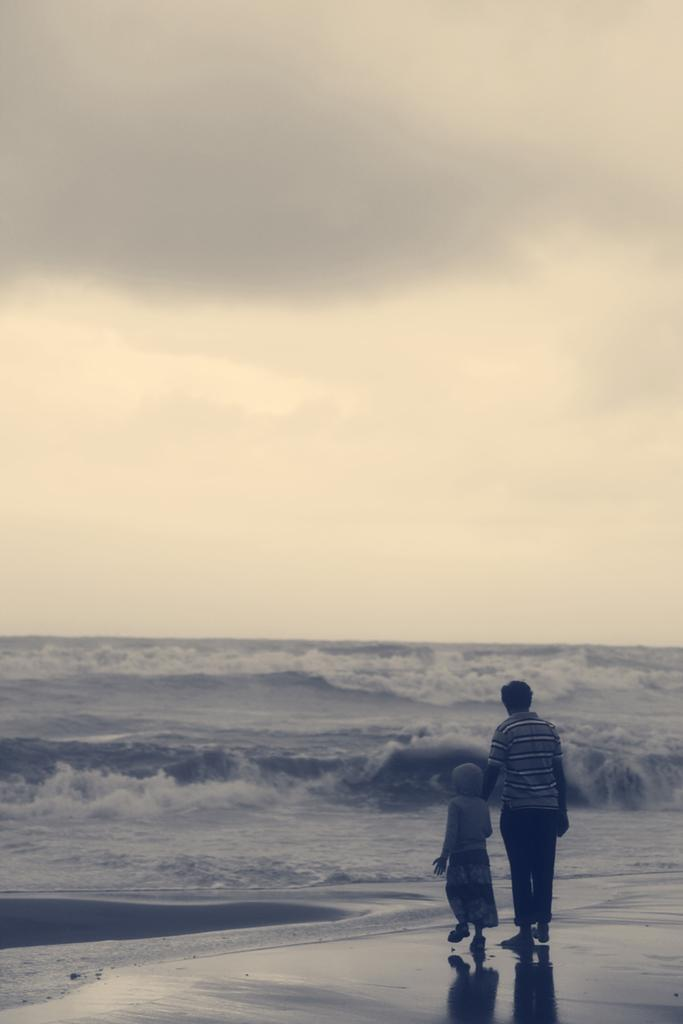What is happening in the center of the image? There are persons standing in the center of the image. What can be seen in the background of the image? There is an ocean in the background of the image. How would you describe the sky in the image? The sky is cloudy in the image. How many beds are visible in the image? There are no beds visible in the image. Can you describe the woman in the image? There is no woman present in the image. 